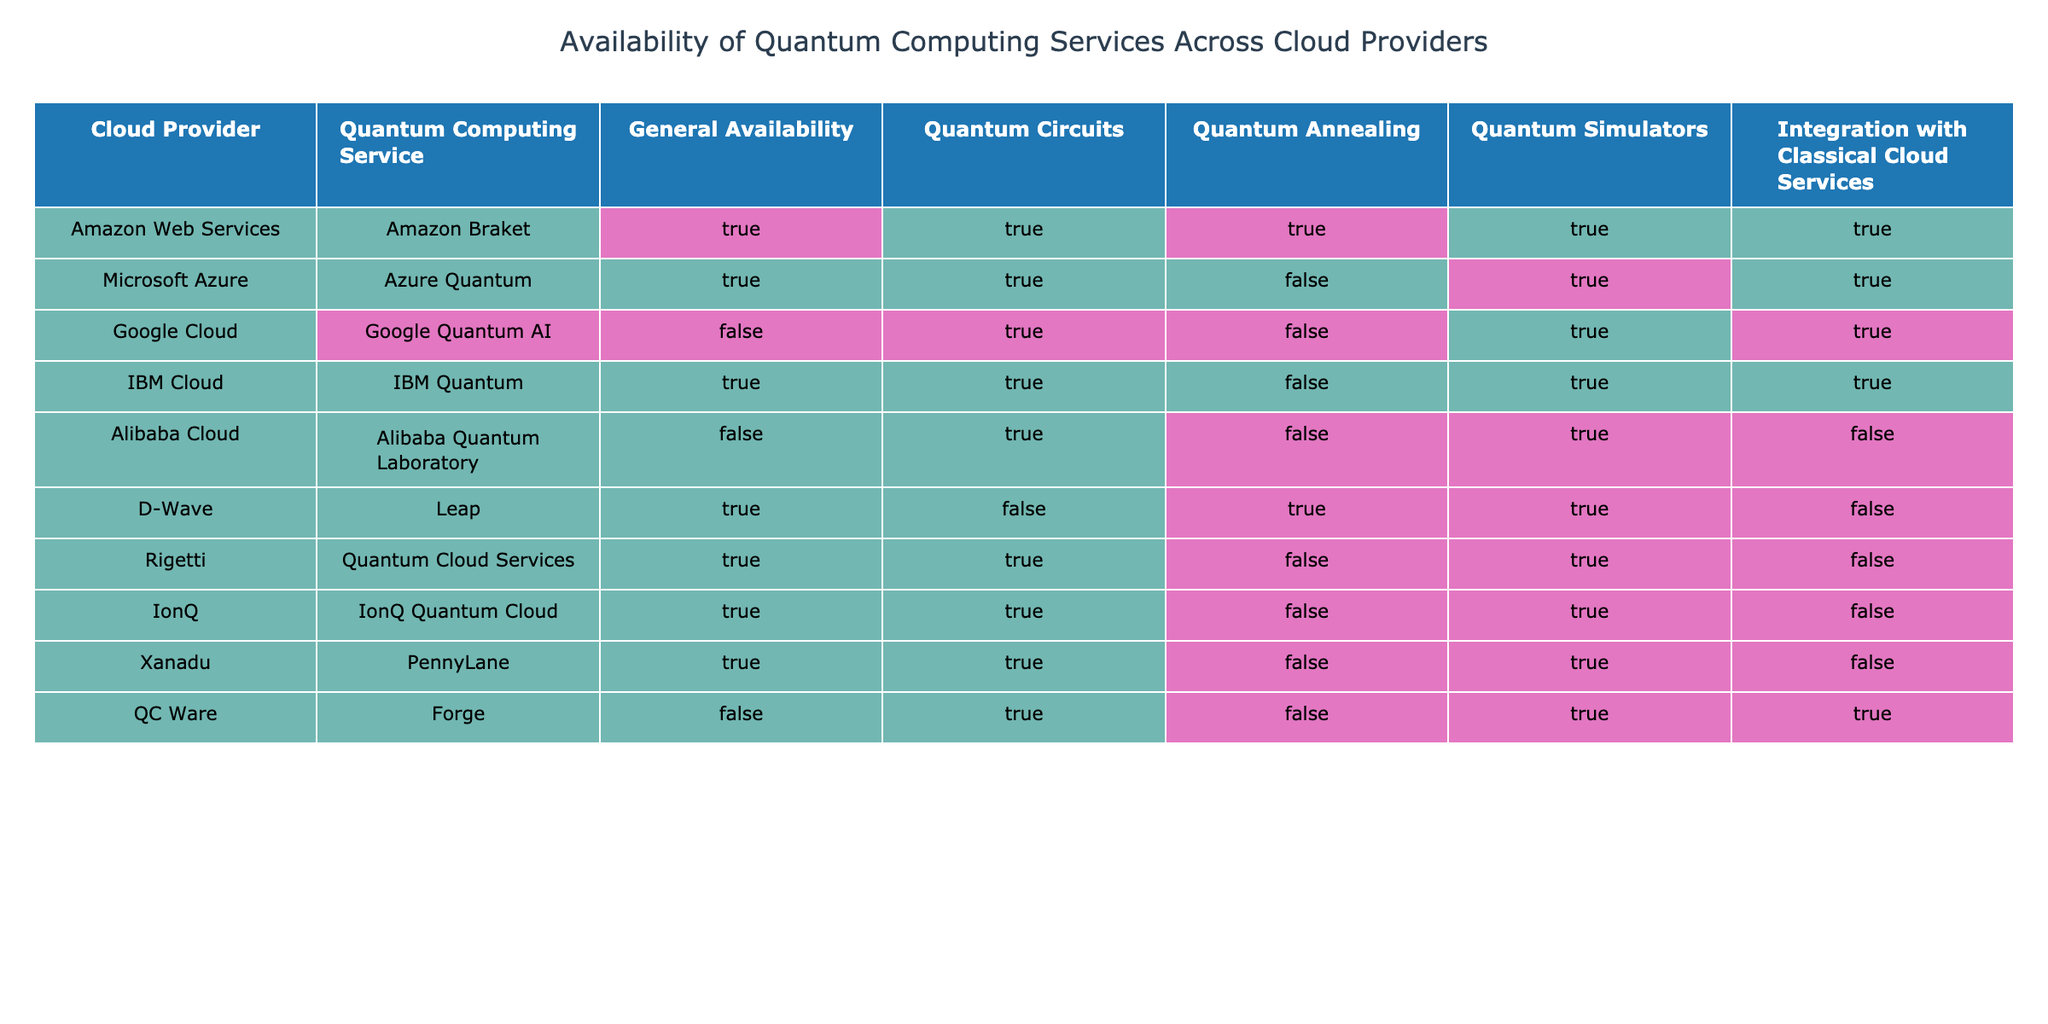What cloud provider offers the service with the highest general availability? By looking at the "General Availability" column, we see that Amazon Web Services, Microsoft Azure, IBM Cloud, D-Wave, Rigetti, IonQ, and Xanadu all have TRUE listed. However, Amazon Web Services has the service mentioned explicitly as available with additional capabilities in all areas, indicating it’s a leading provider.
Answer: Amazon Web Services Which cloud provider does not offer Quantum Annealing services? In the table, we can see that Google Cloud, Microsoft Azure, IBM Cloud, and several others have FALSE for Quantum Annealing, meaning they do not provide this service. However, Google Cloud stands out as it does not provide any Quantum Annealing services and also has a service that is not generally available.
Answer: Google Cloud How many cloud providers provide Quantum Simulators? We can count the rows where "Quantum Simulators" is marked TRUE. Looking through the table, the providers that do have Quantum Simulators are Amazon Web Services, Microsoft Azure, IBM Cloud, D-Wave, Rigetti, IonQ, and Xanadu, which gives us a total of 7 providers offering this service.
Answer: 7 Is there any provider that does not integrate with classical cloud services but has a service that is generally available? Starting with the "General Availability" column, we find providers such as D-Wave, Rigetti, IonQ, and Xanadu are generally available, while looking into the "Integration with Classical Cloud Services" column shows they all have FALSE listed, revealing that D-Wave has a service that's generally available but does not integrate with classical services.
Answer: Yes, D-Wave What is the total number of cloud providers that provide Quantum Circuits and Quantum Simulators? To find this, we first can identify which providers have both columns marked TRUE. When filtering through the table, Amazon Web Services, Microsoft Azure, IBM Cloud, Rigetti, IonQ, and Xanadu each have both options available; thus, we will sum them up. That means 6 cloud providers support both Quantum Circuits and Quantum Simulators.
Answer: 6 Does Alibaba Cloud offer any quantum computing services that are generally available? According to the table, Alibaba Cloud only shows FALSE under "General Availability," meaning none of its quantum services are available generally. Therefore, it can be concluded that Alibaba Cloud does not offer any available services.
Answer: No Which cloud providers have Quantum Circuits as TRUE but do not provide Quantum Annealing capabilities? By checking the table, we see that Amazon Web Services, Microsoft Azure, IBM Cloud, Rigetti, IonQ, and Xanadu have TRUE for Quantum Circuits. From these, Microsoft Azure, IBM Cloud, Rigetti, IonQ, and Xanadu do not offer Quantum Annealing (FALSE). Therefore, the list narrows down to these five providers.
Answer: Microsoft Azure, IBM Cloud, Rigetti, IonQ, Xanadu 